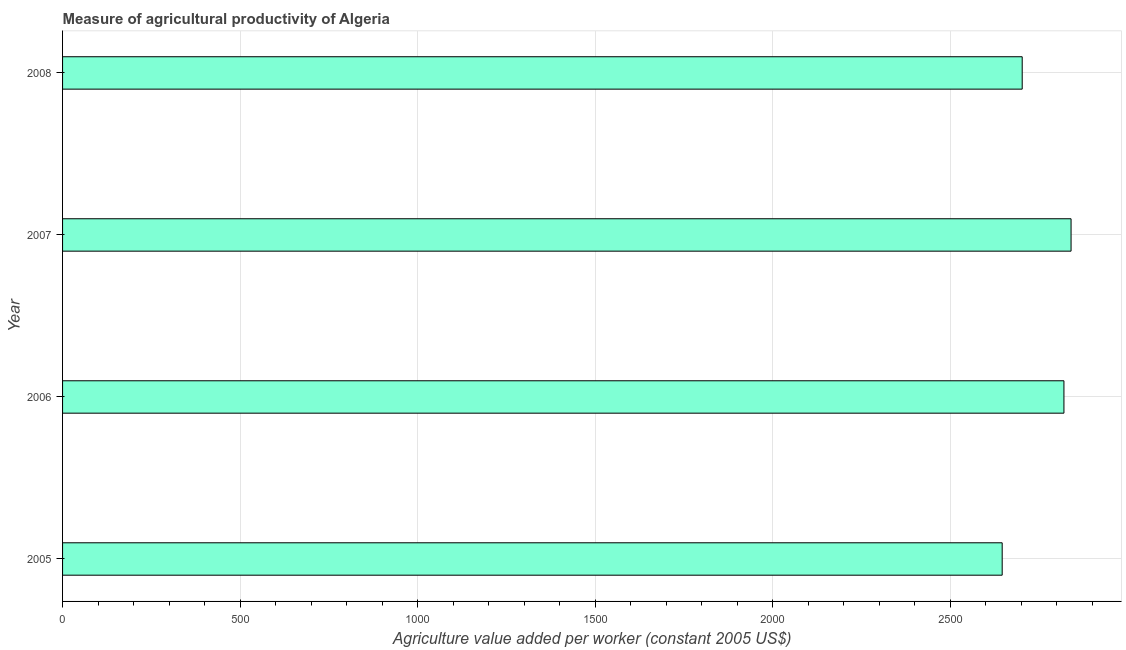Does the graph contain any zero values?
Keep it short and to the point. No. What is the title of the graph?
Make the answer very short. Measure of agricultural productivity of Algeria. What is the label or title of the X-axis?
Provide a succinct answer. Agriculture value added per worker (constant 2005 US$). What is the agriculture value added per worker in 2007?
Provide a short and direct response. 2840.67. Across all years, what is the maximum agriculture value added per worker?
Provide a short and direct response. 2840.67. Across all years, what is the minimum agriculture value added per worker?
Ensure brevity in your answer.  2646.65. In which year was the agriculture value added per worker maximum?
Your response must be concise. 2007. What is the sum of the agriculture value added per worker?
Offer a very short reply. 1.10e+04. What is the difference between the agriculture value added per worker in 2007 and 2008?
Offer a very short reply. 137.63. What is the average agriculture value added per worker per year?
Keep it short and to the point. 2752.74. What is the median agriculture value added per worker?
Your answer should be very brief. 2761.81. In how many years, is the agriculture value added per worker greater than 2800 US$?
Provide a short and direct response. 2. Do a majority of the years between 2008 and 2005 (inclusive) have agriculture value added per worker greater than 700 US$?
Keep it short and to the point. Yes. What is the ratio of the agriculture value added per worker in 2005 to that in 2006?
Provide a short and direct response. 0.94. Is the difference between the agriculture value added per worker in 2005 and 2006 greater than the difference between any two years?
Your answer should be compact. No. What is the difference between the highest and the second highest agriculture value added per worker?
Your answer should be very brief. 20.09. What is the difference between the highest and the lowest agriculture value added per worker?
Your answer should be very brief. 194.03. Are all the bars in the graph horizontal?
Give a very brief answer. Yes. Are the values on the major ticks of X-axis written in scientific E-notation?
Make the answer very short. No. What is the Agriculture value added per worker (constant 2005 US$) in 2005?
Your answer should be compact. 2646.65. What is the Agriculture value added per worker (constant 2005 US$) of 2006?
Offer a terse response. 2820.58. What is the Agriculture value added per worker (constant 2005 US$) in 2007?
Provide a short and direct response. 2840.67. What is the Agriculture value added per worker (constant 2005 US$) of 2008?
Provide a succinct answer. 2703.04. What is the difference between the Agriculture value added per worker (constant 2005 US$) in 2005 and 2006?
Provide a succinct answer. -173.94. What is the difference between the Agriculture value added per worker (constant 2005 US$) in 2005 and 2007?
Your answer should be compact. -194.03. What is the difference between the Agriculture value added per worker (constant 2005 US$) in 2005 and 2008?
Ensure brevity in your answer.  -56.39. What is the difference between the Agriculture value added per worker (constant 2005 US$) in 2006 and 2007?
Provide a short and direct response. -20.09. What is the difference between the Agriculture value added per worker (constant 2005 US$) in 2006 and 2008?
Your answer should be very brief. 117.54. What is the difference between the Agriculture value added per worker (constant 2005 US$) in 2007 and 2008?
Offer a terse response. 137.63. What is the ratio of the Agriculture value added per worker (constant 2005 US$) in 2005 to that in 2006?
Keep it short and to the point. 0.94. What is the ratio of the Agriculture value added per worker (constant 2005 US$) in 2005 to that in 2007?
Your response must be concise. 0.93. What is the ratio of the Agriculture value added per worker (constant 2005 US$) in 2006 to that in 2008?
Your answer should be compact. 1.04. What is the ratio of the Agriculture value added per worker (constant 2005 US$) in 2007 to that in 2008?
Your answer should be very brief. 1.05. 